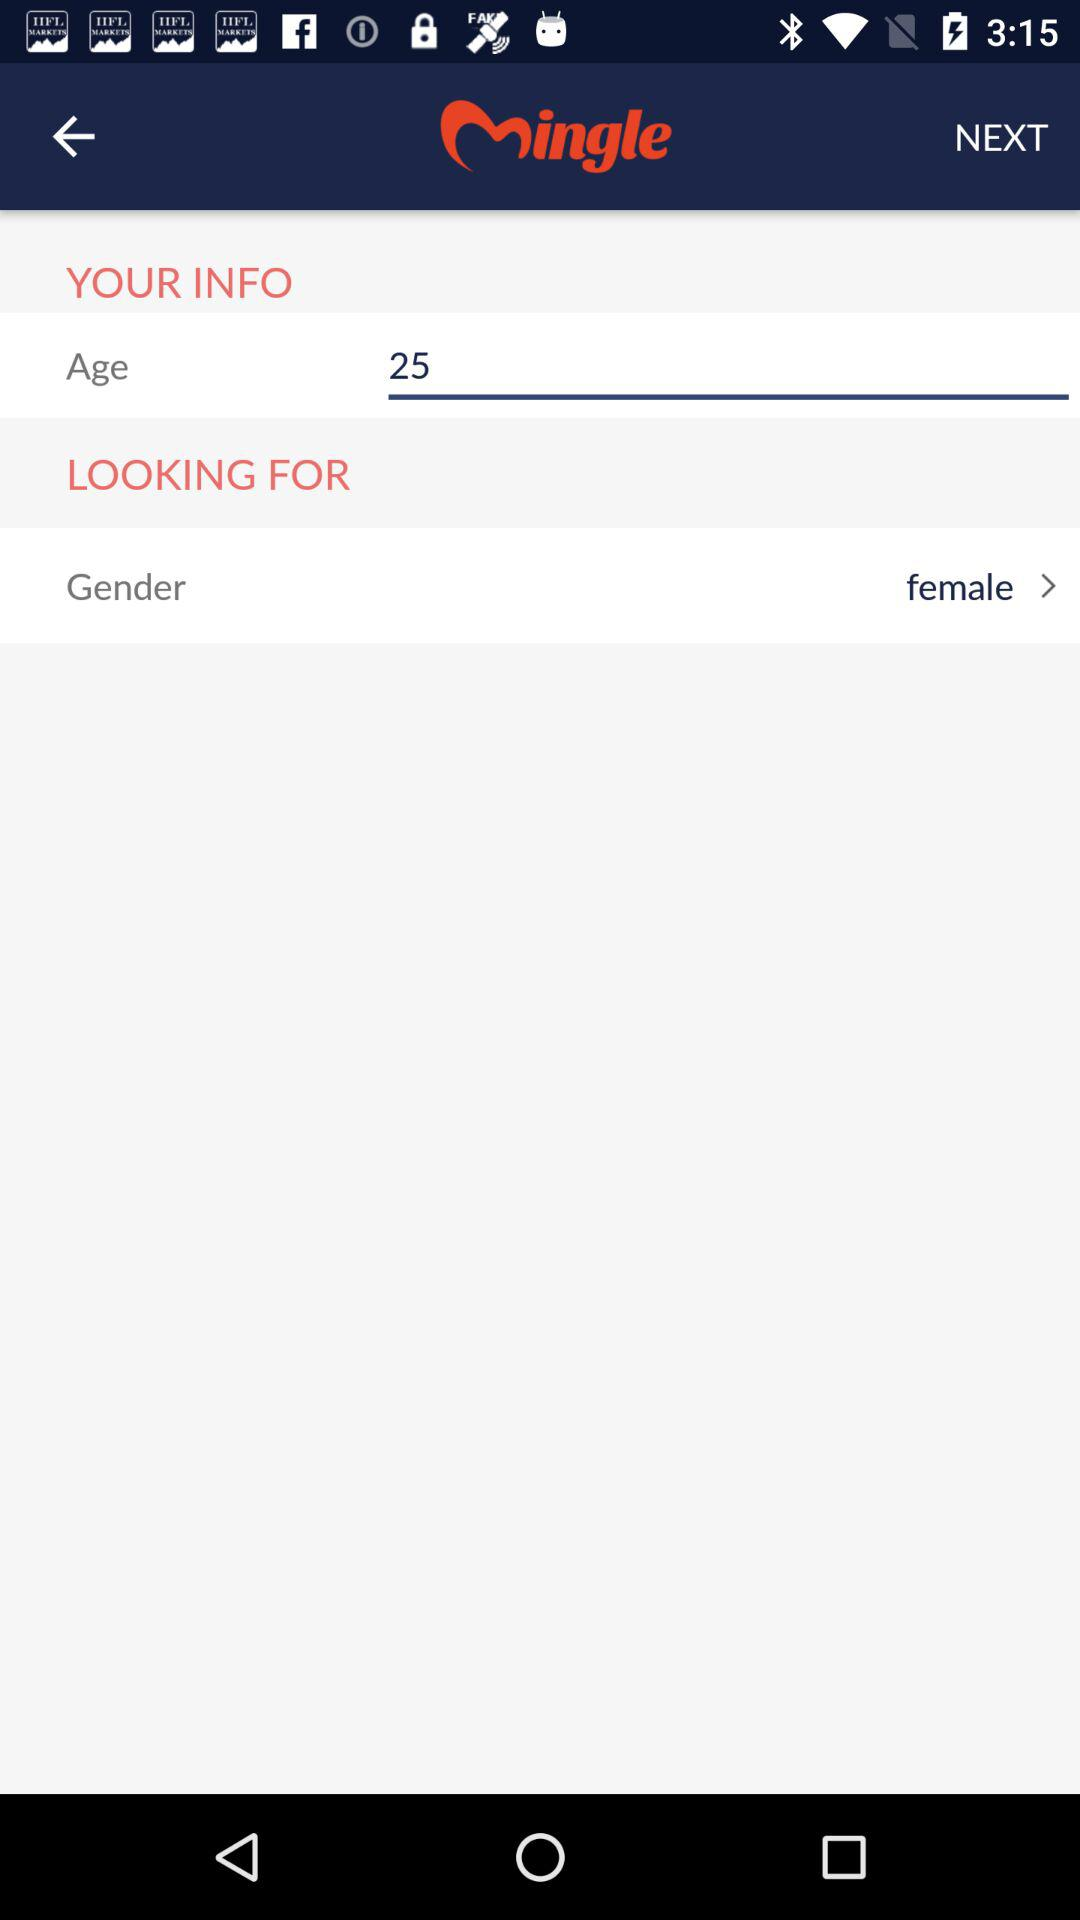What is the name of the application? The name of the application is "Mingle". 